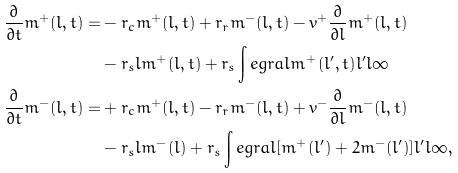Convert formula to latex. <formula><loc_0><loc_0><loc_500><loc_500>\frac { \partial } { \partial t } m ^ { + } ( l , t ) = & - r _ { c } m ^ { + } ( l , t ) + r _ { r } m ^ { - } ( l , t ) - v ^ { + } \frac { \partial } { \partial l } m ^ { + } ( l , t ) \\ & - r _ { s } l m ^ { + } ( l , t ) + r _ { s } \int e g r a l { m ^ { + } ( l ^ { \prime } , t ) } { l ^ { \prime } } { l } { \infty } \\ \frac { \partial } { \partial t } m ^ { - } ( l , t ) = & + r _ { c } m ^ { + } ( l , t ) - r _ { r } m ^ { - } ( l , t ) + v ^ { - } \frac { \partial } { \partial l } m ^ { - } ( l , t ) \\ & - r _ { s } l m ^ { - } ( l ) + r _ { s } \int e g r a l { [ m ^ { + } ( l ^ { \prime } ) + 2 m ^ { - } ( l ^ { \prime } ) ] } { l ^ { \prime } } { l } { \infty } ,</formula> 